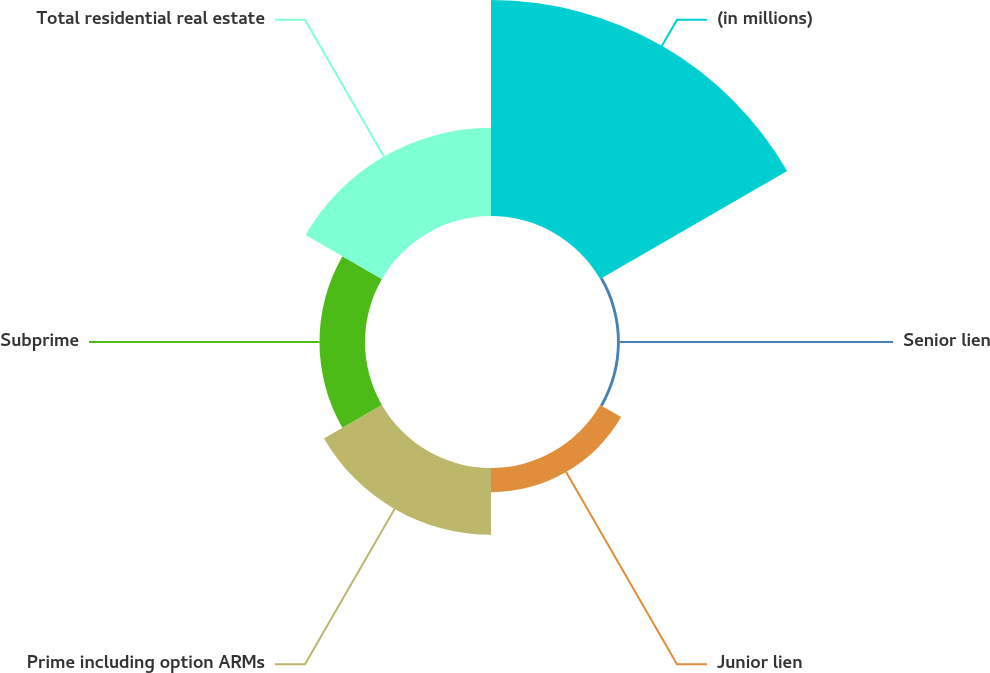<chart> <loc_0><loc_0><loc_500><loc_500><pie_chart><fcel>(in millions)<fcel>Senior lien<fcel>Junior lien<fcel>Prime including option ARMs<fcel>Subprime<fcel>Total residential real estate<nl><fcel>48.69%<fcel>0.65%<fcel>5.46%<fcel>15.07%<fcel>10.26%<fcel>19.87%<nl></chart> 